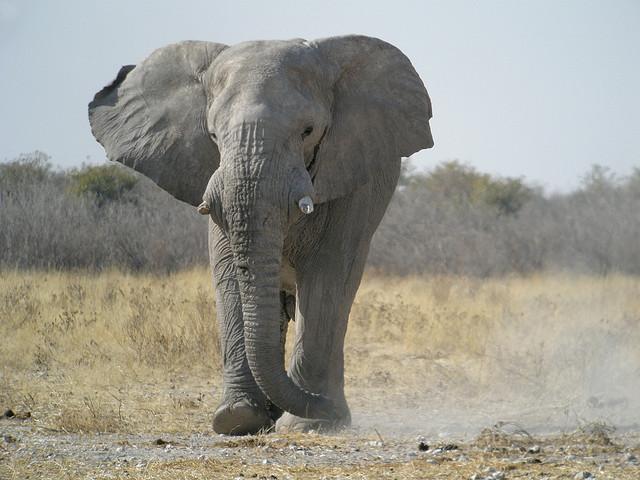How many elephants are shown?
Give a very brief answer. 1. How many trunks?
Give a very brief answer. 1. How many tusks are in the picture?
Give a very brief answer. 2. How many babies are in the picture?
Give a very brief answer. 0. 